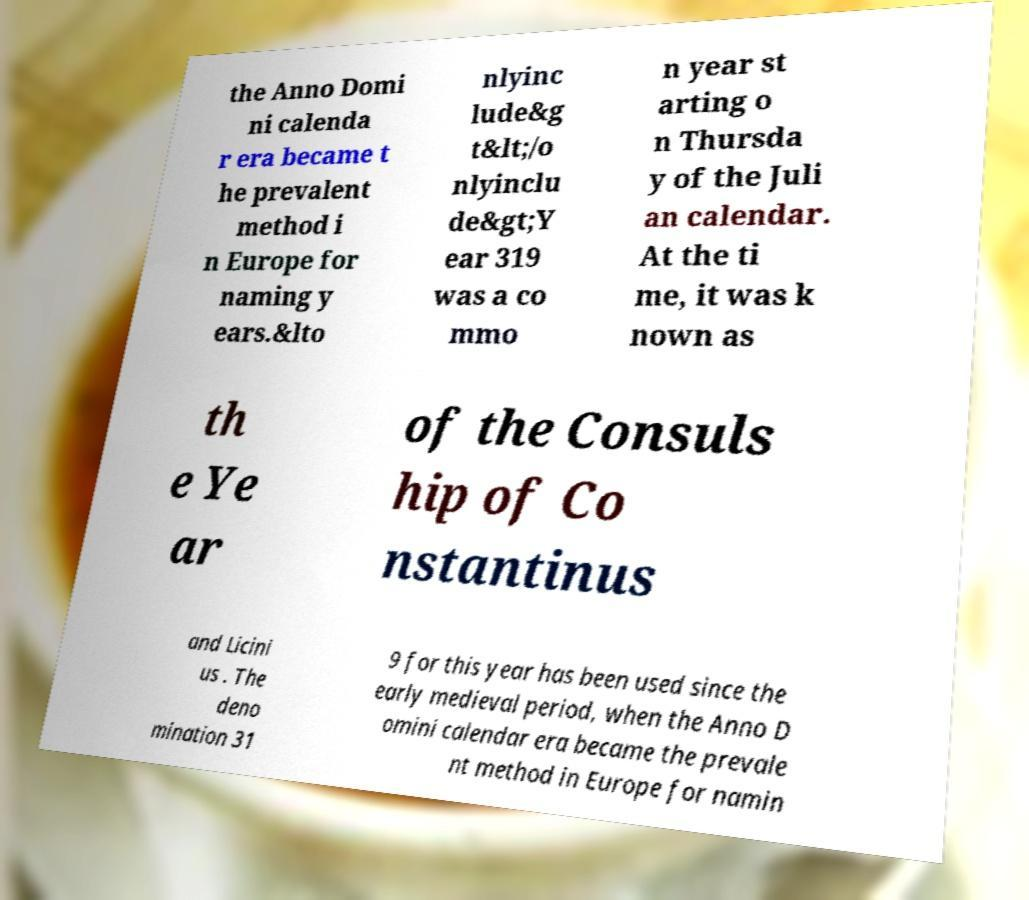Could you assist in decoding the text presented in this image and type it out clearly? the Anno Domi ni calenda r era became t he prevalent method i n Europe for naming y ears.&lto nlyinc lude&g t&lt;/o nlyinclu de&gt;Y ear 319 was a co mmo n year st arting o n Thursda y of the Juli an calendar. At the ti me, it was k nown as th e Ye ar of the Consuls hip of Co nstantinus and Licini us . The deno mination 31 9 for this year has been used since the early medieval period, when the Anno D omini calendar era became the prevale nt method in Europe for namin 